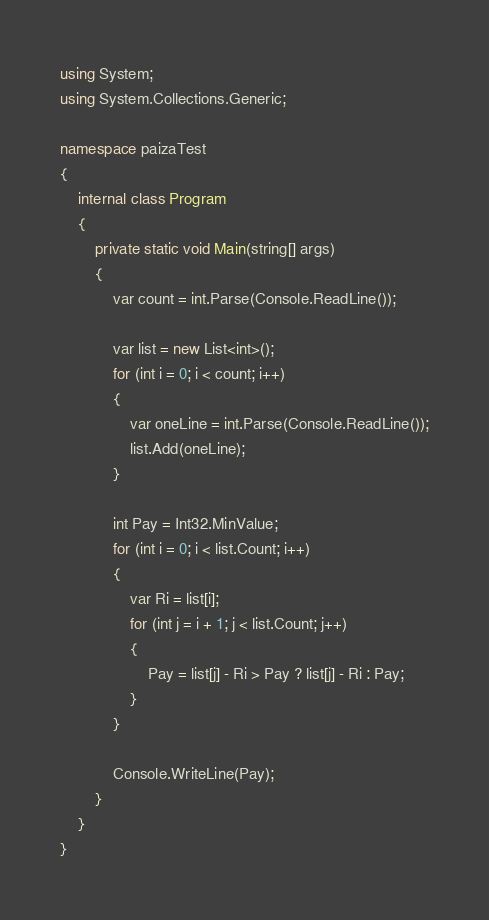<code> <loc_0><loc_0><loc_500><loc_500><_C#_>using System;
using System.Collections.Generic;

namespace paizaTest
{
    internal class Program
    {
        private static void Main(string[] args)
        {
            var count = int.Parse(Console.ReadLine());

            var list = new List<int>();
            for (int i = 0; i < count; i++)
            {
                var oneLine = int.Parse(Console.ReadLine());
                list.Add(oneLine);
            }

            int Pay = Int32.MinValue;
            for (int i = 0; i < list.Count; i++)
            {
                var Ri = list[i];
                for (int j = i + 1; j < list.Count; j++)
                {
                    Pay = list[j] - Ri > Pay ? list[j] - Ri : Pay;
                }
            }

            Console.WriteLine(Pay);
        }
    }
}</code> 